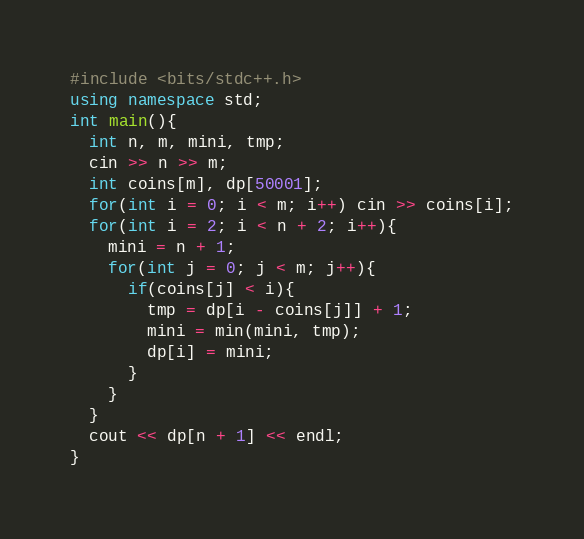Convert code to text. <code><loc_0><loc_0><loc_500><loc_500><_C++_>#include <bits/stdc++.h>
using namespace std;
int main(){
  int n, m, mini, tmp;
  cin >> n >> m;
  int coins[m], dp[50001];
  for(int i = 0; i < m; i++) cin >> coins[i];
  for(int i = 2; i < n + 2; i++){
    mini = n + 1;
    for(int j = 0; j < m; j++){
      if(coins[j] < i){
        tmp = dp[i - coins[j]] + 1;
        mini = min(mini, tmp);
        dp[i] = mini;
      }  
    }
  }
  cout << dp[n + 1] << endl;
}

</code> 